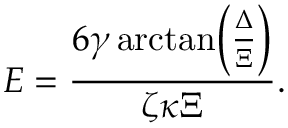<formula> <loc_0><loc_0><loc_500><loc_500>E = \frac { 6 \gamma \arctan \, \left ( \frac { \Delta } { \Xi } \right ) } { \zeta \kappa \Xi } .</formula> 